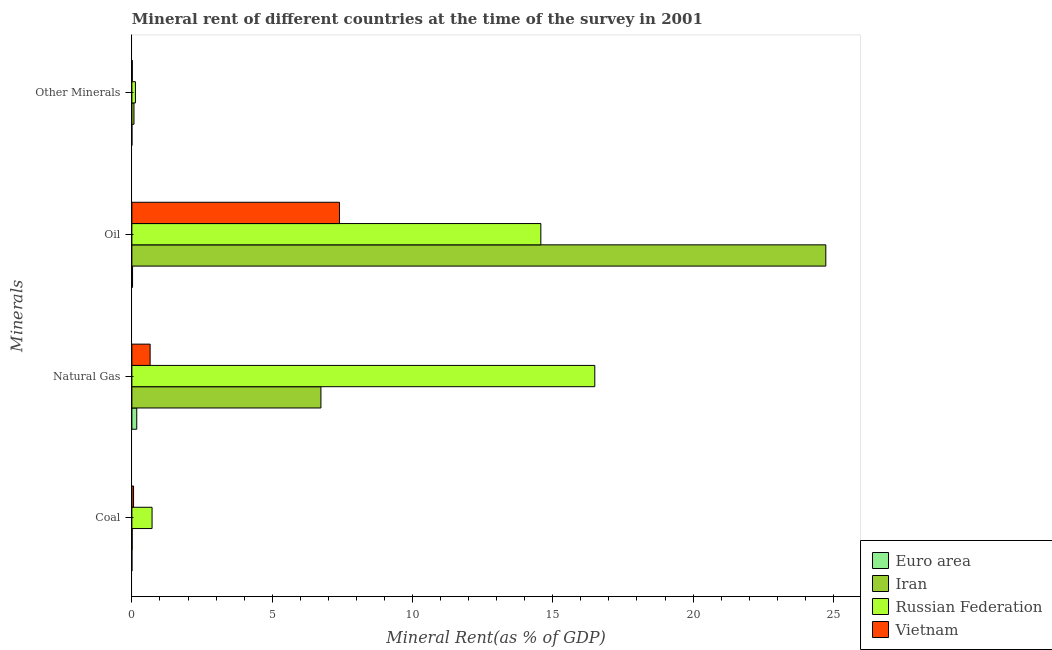Are the number of bars on each tick of the Y-axis equal?
Give a very brief answer. Yes. How many bars are there on the 3rd tick from the top?
Your answer should be very brief. 4. How many bars are there on the 2nd tick from the bottom?
Keep it short and to the point. 4. What is the label of the 2nd group of bars from the top?
Provide a succinct answer. Oil. What is the coal rent in Iran?
Give a very brief answer. 0.01. Across all countries, what is the maximum natural gas rent?
Provide a succinct answer. 16.5. Across all countries, what is the minimum coal rent?
Ensure brevity in your answer.  0. In which country was the natural gas rent maximum?
Give a very brief answer. Russian Federation. What is the total oil rent in the graph?
Your answer should be very brief. 46.73. What is the difference between the  rent of other minerals in Iran and that in Vietnam?
Give a very brief answer. 0.06. What is the difference between the natural gas rent in Russian Federation and the  rent of other minerals in Vietnam?
Offer a very short reply. 16.48. What is the average coal rent per country?
Your answer should be very brief. 0.2. What is the difference between the natural gas rent and coal rent in Vietnam?
Offer a terse response. 0.59. In how many countries, is the coal rent greater than 8 %?
Your response must be concise. 0. What is the ratio of the oil rent in Russian Federation to that in Vietnam?
Ensure brevity in your answer.  1.97. What is the difference between the highest and the second highest natural gas rent?
Provide a short and direct response. 9.76. What is the difference between the highest and the lowest  rent of other minerals?
Provide a succinct answer. 0.13. Is the sum of the coal rent in Euro area and Vietnam greater than the maximum natural gas rent across all countries?
Ensure brevity in your answer.  No. What does the 3rd bar from the top in Natural Gas represents?
Ensure brevity in your answer.  Iran. What does the 2nd bar from the bottom in Coal represents?
Offer a very short reply. Iran. Is it the case that in every country, the sum of the coal rent and natural gas rent is greater than the oil rent?
Your response must be concise. No. How many bars are there?
Ensure brevity in your answer.  16. How many countries are there in the graph?
Offer a terse response. 4. What is the difference between two consecutive major ticks on the X-axis?
Keep it short and to the point. 5. Does the graph contain grids?
Your response must be concise. No. How many legend labels are there?
Keep it short and to the point. 4. What is the title of the graph?
Your answer should be compact. Mineral rent of different countries at the time of the survey in 2001. Does "Lithuania" appear as one of the legend labels in the graph?
Keep it short and to the point. No. What is the label or title of the X-axis?
Your answer should be compact. Mineral Rent(as % of GDP). What is the label or title of the Y-axis?
Your response must be concise. Minerals. What is the Mineral Rent(as % of GDP) in Euro area in Coal?
Keep it short and to the point. 0. What is the Mineral Rent(as % of GDP) in Iran in Coal?
Your answer should be very brief. 0.01. What is the Mineral Rent(as % of GDP) in Russian Federation in Coal?
Provide a short and direct response. 0.72. What is the Mineral Rent(as % of GDP) in Vietnam in Coal?
Keep it short and to the point. 0.06. What is the Mineral Rent(as % of GDP) of Euro area in Natural Gas?
Provide a succinct answer. 0.17. What is the Mineral Rent(as % of GDP) of Iran in Natural Gas?
Provide a succinct answer. 6.74. What is the Mineral Rent(as % of GDP) in Russian Federation in Natural Gas?
Your answer should be very brief. 16.5. What is the Mineral Rent(as % of GDP) in Vietnam in Natural Gas?
Provide a short and direct response. 0.65. What is the Mineral Rent(as % of GDP) in Euro area in Oil?
Your response must be concise. 0.02. What is the Mineral Rent(as % of GDP) of Iran in Oil?
Your answer should be very brief. 24.73. What is the Mineral Rent(as % of GDP) in Russian Federation in Oil?
Offer a very short reply. 14.57. What is the Mineral Rent(as % of GDP) of Vietnam in Oil?
Ensure brevity in your answer.  7.4. What is the Mineral Rent(as % of GDP) in Euro area in Other Minerals?
Your response must be concise. 0. What is the Mineral Rent(as % of GDP) of Iran in Other Minerals?
Your answer should be very brief. 0.08. What is the Mineral Rent(as % of GDP) of Russian Federation in Other Minerals?
Your answer should be very brief. 0.13. What is the Mineral Rent(as % of GDP) of Vietnam in Other Minerals?
Your answer should be very brief. 0.01. Across all Minerals, what is the maximum Mineral Rent(as % of GDP) in Euro area?
Your answer should be compact. 0.17. Across all Minerals, what is the maximum Mineral Rent(as % of GDP) of Iran?
Ensure brevity in your answer.  24.73. Across all Minerals, what is the maximum Mineral Rent(as % of GDP) in Russian Federation?
Your answer should be very brief. 16.5. Across all Minerals, what is the maximum Mineral Rent(as % of GDP) in Vietnam?
Ensure brevity in your answer.  7.4. Across all Minerals, what is the minimum Mineral Rent(as % of GDP) of Euro area?
Provide a short and direct response. 0. Across all Minerals, what is the minimum Mineral Rent(as % of GDP) of Iran?
Provide a short and direct response. 0.01. Across all Minerals, what is the minimum Mineral Rent(as % of GDP) of Russian Federation?
Your response must be concise. 0.13. Across all Minerals, what is the minimum Mineral Rent(as % of GDP) of Vietnam?
Keep it short and to the point. 0.01. What is the total Mineral Rent(as % of GDP) of Euro area in the graph?
Your answer should be very brief. 0.2. What is the total Mineral Rent(as % of GDP) of Iran in the graph?
Your response must be concise. 31.55. What is the total Mineral Rent(as % of GDP) in Russian Federation in the graph?
Ensure brevity in your answer.  31.92. What is the total Mineral Rent(as % of GDP) in Vietnam in the graph?
Your answer should be compact. 8.12. What is the difference between the Mineral Rent(as % of GDP) of Euro area in Coal and that in Natural Gas?
Provide a short and direct response. -0.17. What is the difference between the Mineral Rent(as % of GDP) in Iran in Coal and that in Natural Gas?
Ensure brevity in your answer.  -6.73. What is the difference between the Mineral Rent(as % of GDP) in Russian Federation in Coal and that in Natural Gas?
Keep it short and to the point. -15.78. What is the difference between the Mineral Rent(as % of GDP) in Vietnam in Coal and that in Natural Gas?
Make the answer very short. -0.59. What is the difference between the Mineral Rent(as % of GDP) of Euro area in Coal and that in Oil?
Your answer should be compact. -0.02. What is the difference between the Mineral Rent(as % of GDP) of Iran in Coal and that in Oil?
Ensure brevity in your answer.  -24.72. What is the difference between the Mineral Rent(as % of GDP) in Russian Federation in Coal and that in Oil?
Provide a short and direct response. -13.86. What is the difference between the Mineral Rent(as % of GDP) in Vietnam in Coal and that in Oil?
Give a very brief answer. -7.34. What is the difference between the Mineral Rent(as % of GDP) in Iran in Coal and that in Other Minerals?
Provide a short and direct response. -0.06. What is the difference between the Mineral Rent(as % of GDP) in Russian Federation in Coal and that in Other Minerals?
Provide a succinct answer. 0.59. What is the difference between the Mineral Rent(as % of GDP) in Vietnam in Coal and that in Other Minerals?
Your answer should be very brief. 0.05. What is the difference between the Mineral Rent(as % of GDP) of Euro area in Natural Gas and that in Oil?
Your answer should be very brief. 0.15. What is the difference between the Mineral Rent(as % of GDP) of Iran in Natural Gas and that in Oil?
Your answer should be compact. -17.99. What is the difference between the Mineral Rent(as % of GDP) in Russian Federation in Natural Gas and that in Oil?
Offer a very short reply. 1.92. What is the difference between the Mineral Rent(as % of GDP) in Vietnam in Natural Gas and that in Oil?
Offer a very short reply. -6.75. What is the difference between the Mineral Rent(as % of GDP) of Euro area in Natural Gas and that in Other Minerals?
Make the answer very short. 0.17. What is the difference between the Mineral Rent(as % of GDP) of Iran in Natural Gas and that in Other Minerals?
Keep it short and to the point. 6.66. What is the difference between the Mineral Rent(as % of GDP) of Russian Federation in Natural Gas and that in Other Minerals?
Offer a terse response. 16.37. What is the difference between the Mineral Rent(as % of GDP) of Vietnam in Natural Gas and that in Other Minerals?
Offer a very short reply. 0.64. What is the difference between the Mineral Rent(as % of GDP) of Euro area in Oil and that in Other Minerals?
Offer a terse response. 0.02. What is the difference between the Mineral Rent(as % of GDP) in Iran in Oil and that in Other Minerals?
Provide a short and direct response. 24.66. What is the difference between the Mineral Rent(as % of GDP) of Russian Federation in Oil and that in Other Minerals?
Ensure brevity in your answer.  14.45. What is the difference between the Mineral Rent(as % of GDP) of Vietnam in Oil and that in Other Minerals?
Offer a terse response. 7.38. What is the difference between the Mineral Rent(as % of GDP) of Euro area in Coal and the Mineral Rent(as % of GDP) of Iran in Natural Gas?
Ensure brevity in your answer.  -6.74. What is the difference between the Mineral Rent(as % of GDP) of Euro area in Coal and the Mineral Rent(as % of GDP) of Russian Federation in Natural Gas?
Offer a terse response. -16.5. What is the difference between the Mineral Rent(as % of GDP) of Euro area in Coal and the Mineral Rent(as % of GDP) of Vietnam in Natural Gas?
Your response must be concise. -0.65. What is the difference between the Mineral Rent(as % of GDP) of Iran in Coal and the Mineral Rent(as % of GDP) of Russian Federation in Natural Gas?
Ensure brevity in your answer.  -16.49. What is the difference between the Mineral Rent(as % of GDP) of Iran in Coal and the Mineral Rent(as % of GDP) of Vietnam in Natural Gas?
Your answer should be compact. -0.64. What is the difference between the Mineral Rent(as % of GDP) of Russian Federation in Coal and the Mineral Rent(as % of GDP) of Vietnam in Natural Gas?
Keep it short and to the point. 0.07. What is the difference between the Mineral Rent(as % of GDP) of Euro area in Coal and the Mineral Rent(as % of GDP) of Iran in Oil?
Offer a terse response. -24.73. What is the difference between the Mineral Rent(as % of GDP) of Euro area in Coal and the Mineral Rent(as % of GDP) of Russian Federation in Oil?
Make the answer very short. -14.57. What is the difference between the Mineral Rent(as % of GDP) of Euro area in Coal and the Mineral Rent(as % of GDP) of Vietnam in Oil?
Your answer should be very brief. -7.4. What is the difference between the Mineral Rent(as % of GDP) of Iran in Coal and the Mineral Rent(as % of GDP) of Russian Federation in Oil?
Make the answer very short. -14.56. What is the difference between the Mineral Rent(as % of GDP) in Iran in Coal and the Mineral Rent(as % of GDP) in Vietnam in Oil?
Ensure brevity in your answer.  -7.39. What is the difference between the Mineral Rent(as % of GDP) in Russian Federation in Coal and the Mineral Rent(as % of GDP) in Vietnam in Oil?
Your answer should be very brief. -6.68. What is the difference between the Mineral Rent(as % of GDP) of Euro area in Coal and the Mineral Rent(as % of GDP) of Iran in Other Minerals?
Keep it short and to the point. -0.07. What is the difference between the Mineral Rent(as % of GDP) of Euro area in Coal and the Mineral Rent(as % of GDP) of Russian Federation in Other Minerals?
Give a very brief answer. -0.13. What is the difference between the Mineral Rent(as % of GDP) in Euro area in Coal and the Mineral Rent(as % of GDP) in Vietnam in Other Minerals?
Ensure brevity in your answer.  -0.01. What is the difference between the Mineral Rent(as % of GDP) of Iran in Coal and the Mineral Rent(as % of GDP) of Russian Federation in Other Minerals?
Make the answer very short. -0.12. What is the difference between the Mineral Rent(as % of GDP) of Iran in Coal and the Mineral Rent(as % of GDP) of Vietnam in Other Minerals?
Give a very brief answer. -0. What is the difference between the Mineral Rent(as % of GDP) of Russian Federation in Coal and the Mineral Rent(as % of GDP) of Vietnam in Other Minerals?
Your answer should be very brief. 0.7. What is the difference between the Mineral Rent(as % of GDP) in Euro area in Natural Gas and the Mineral Rent(as % of GDP) in Iran in Oil?
Keep it short and to the point. -24.56. What is the difference between the Mineral Rent(as % of GDP) in Euro area in Natural Gas and the Mineral Rent(as % of GDP) in Russian Federation in Oil?
Your answer should be compact. -14.4. What is the difference between the Mineral Rent(as % of GDP) of Euro area in Natural Gas and the Mineral Rent(as % of GDP) of Vietnam in Oil?
Provide a short and direct response. -7.22. What is the difference between the Mineral Rent(as % of GDP) in Iran in Natural Gas and the Mineral Rent(as % of GDP) in Russian Federation in Oil?
Offer a terse response. -7.84. What is the difference between the Mineral Rent(as % of GDP) in Iran in Natural Gas and the Mineral Rent(as % of GDP) in Vietnam in Oil?
Offer a terse response. -0.66. What is the difference between the Mineral Rent(as % of GDP) in Russian Federation in Natural Gas and the Mineral Rent(as % of GDP) in Vietnam in Oil?
Provide a short and direct response. 9.1. What is the difference between the Mineral Rent(as % of GDP) in Euro area in Natural Gas and the Mineral Rent(as % of GDP) in Iran in Other Minerals?
Ensure brevity in your answer.  0.1. What is the difference between the Mineral Rent(as % of GDP) in Euro area in Natural Gas and the Mineral Rent(as % of GDP) in Russian Federation in Other Minerals?
Offer a terse response. 0.05. What is the difference between the Mineral Rent(as % of GDP) of Euro area in Natural Gas and the Mineral Rent(as % of GDP) of Vietnam in Other Minerals?
Make the answer very short. 0.16. What is the difference between the Mineral Rent(as % of GDP) in Iran in Natural Gas and the Mineral Rent(as % of GDP) in Russian Federation in Other Minerals?
Your answer should be very brief. 6.61. What is the difference between the Mineral Rent(as % of GDP) of Iran in Natural Gas and the Mineral Rent(as % of GDP) of Vietnam in Other Minerals?
Offer a terse response. 6.72. What is the difference between the Mineral Rent(as % of GDP) in Russian Federation in Natural Gas and the Mineral Rent(as % of GDP) in Vietnam in Other Minerals?
Provide a short and direct response. 16.48. What is the difference between the Mineral Rent(as % of GDP) of Euro area in Oil and the Mineral Rent(as % of GDP) of Iran in Other Minerals?
Ensure brevity in your answer.  -0.05. What is the difference between the Mineral Rent(as % of GDP) of Euro area in Oil and the Mineral Rent(as % of GDP) of Russian Federation in Other Minerals?
Keep it short and to the point. -0.1. What is the difference between the Mineral Rent(as % of GDP) of Euro area in Oil and the Mineral Rent(as % of GDP) of Vietnam in Other Minerals?
Your answer should be compact. 0.01. What is the difference between the Mineral Rent(as % of GDP) of Iran in Oil and the Mineral Rent(as % of GDP) of Russian Federation in Other Minerals?
Ensure brevity in your answer.  24.6. What is the difference between the Mineral Rent(as % of GDP) in Iran in Oil and the Mineral Rent(as % of GDP) in Vietnam in Other Minerals?
Offer a very short reply. 24.72. What is the difference between the Mineral Rent(as % of GDP) of Russian Federation in Oil and the Mineral Rent(as % of GDP) of Vietnam in Other Minerals?
Provide a short and direct response. 14.56. What is the average Mineral Rent(as % of GDP) in Euro area per Minerals?
Offer a very short reply. 0.05. What is the average Mineral Rent(as % of GDP) in Iran per Minerals?
Provide a succinct answer. 7.89. What is the average Mineral Rent(as % of GDP) of Russian Federation per Minerals?
Provide a short and direct response. 7.98. What is the average Mineral Rent(as % of GDP) in Vietnam per Minerals?
Give a very brief answer. 2.03. What is the difference between the Mineral Rent(as % of GDP) of Euro area and Mineral Rent(as % of GDP) of Iran in Coal?
Provide a short and direct response. -0.01. What is the difference between the Mineral Rent(as % of GDP) in Euro area and Mineral Rent(as % of GDP) in Russian Federation in Coal?
Provide a succinct answer. -0.72. What is the difference between the Mineral Rent(as % of GDP) of Euro area and Mineral Rent(as % of GDP) of Vietnam in Coal?
Keep it short and to the point. -0.06. What is the difference between the Mineral Rent(as % of GDP) of Iran and Mineral Rent(as % of GDP) of Russian Federation in Coal?
Ensure brevity in your answer.  -0.71. What is the difference between the Mineral Rent(as % of GDP) in Iran and Mineral Rent(as % of GDP) in Vietnam in Coal?
Ensure brevity in your answer.  -0.05. What is the difference between the Mineral Rent(as % of GDP) in Russian Federation and Mineral Rent(as % of GDP) in Vietnam in Coal?
Your answer should be compact. 0.66. What is the difference between the Mineral Rent(as % of GDP) of Euro area and Mineral Rent(as % of GDP) of Iran in Natural Gas?
Your answer should be very brief. -6.56. What is the difference between the Mineral Rent(as % of GDP) in Euro area and Mineral Rent(as % of GDP) in Russian Federation in Natural Gas?
Ensure brevity in your answer.  -16.32. What is the difference between the Mineral Rent(as % of GDP) in Euro area and Mineral Rent(as % of GDP) in Vietnam in Natural Gas?
Ensure brevity in your answer.  -0.48. What is the difference between the Mineral Rent(as % of GDP) in Iran and Mineral Rent(as % of GDP) in Russian Federation in Natural Gas?
Your response must be concise. -9.76. What is the difference between the Mineral Rent(as % of GDP) in Iran and Mineral Rent(as % of GDP) in Vietnam in Natural Gas?
Make the answer very short. 6.09. What is the difference between the Mineral Rent(as % of GDP) in Russian Federation and Mineral Rent(as % of GDP) in Vietnam in Natural Gas?
Provide a short and direct response. 15.85. What is the difference between the Mineral Rent(as % of GDP) in Euro area and Mineral Rent(as % of GDP) in Iran in Oil?
Provide a succinct answer. -24.71. What is the difference between the Mineral Rent(as % of GDP) of Euro area and Mineral Rent(as % of GDP) of Russian Federation in Oil?
Keep it short and to the point. -14.55. What is the difference between the Mineral Rent(as % of GDP) in Euro area and Mineral Rent(as % of GDP) in Vietnam in Oil?
Your answer should be compact. -7.37. What is the difference between the Mineral Rent(as % of GDP) of Iran and Mineral Rent(as % of GDP) of Russian Federation in Oil?
Your response must be concise. 10.16. What is the difference between the Mineral Rent(as % of GDP) of Iran and Mineral Rent(as % of GDP) of Vietnam in Oil?
Keep it short and to the point. 17.33. What is the difference between the Mineral Rent(as % of GDP) in Russian Federation and Mineral Rent(as % of GDP) in Vietnam in Oil?
Ensure brevity in your answer.  7.18. What is the difference between the Mineral Rent(as % of GDP) in Euro area and Mineral Rent(as % of GDP) in Iran in Other Minerals?
Provide a short and direct response. -0.07. What is the difference between the Mineral Rent(as % of GDP) in Euro area and Mineral Rent(as % of GDP) in Russian Federation in Other Minerals?
Your answer should be compact. -0.13. What is the difference between the Mineral Rent(as % of GDP) in Euro area and Mineral Rent(as % of GDP) in Vietnam in Other Minerals?
Provide a short and direct response. -0.01. What is the difference between the Mineral Rent(as % of GDP) of Iran and Mineral Rent(as % of GDP) of Russian Federation in Other Minerals?
Offer a terse response. -0.05. What is the difference between the Mineral Rent(as % of GDP) of Iran and Mineral Rent(as % of GDP) of Vietnam in Other Minerals?
Your answer should be compact. 0.06. What is the difference between the Mineral Rent(as % of GDP) in Russian Federation and Mineral Rent(as % of GDP) in Vietnam in Other Minerals?
Make the answer very short. 0.11. What is the ratio of the Mineral Rent(as % of GDP) in Euro area in Coal to that in Natural Gas?
Give a very brief answer. 0. What is the ratio of the Mineral Rent(as % of GDP) of Iran in Coal to that in Natural Gas?
Keep it short and to the point. 0. What is the ratio of the Mineral Rent(as % of GDP) of Russian Federation in Coal to that in Natural Gas?
Provide a short and direct response. 0.04. What is the ratio of the Mineral Rent(as % of GDP) of Vietnam in Coal to that in Natural Gas?
Provide a short and direct response. 0.09. What is the ratio of the Mineral Rent(as % of GDP) in Euro area in Coal to that in Oil?
Give a very brief answer. 0.02. What is the ratio of the Mineral Rent(as % of GDP) in Russian Federation in Coal to that in Oil?
Offer a terse response. 0.05. What is the ratio of the Mineral Rent(as % of GDP) of Vietnam in Coal to that in Oil?
Give a very brief answer. 0.01. What is the ratio of the Mineral Rent(as % of GDP) in Euro area in Coal to that in Other Minerals?
Your answer should be very brief. 1.13. What is the ratio of the Mineral Rent(as % of GDP) in Iran in Coal to that in Other Minerals?
Give a very brief answer. 0.14. What is the ratio of the Mineral Rent(as % of GDP) of Russian Federation in Coal to that in Other Minerals?
Keep it short and to the point. 5.67. What is the ratio of the Mineral Rent(as % of GDP) in Vietnam in Coal to that in Other Minerals?
Your answer should be very brief. 4.01. What is the ratio of the Mineral Rent(as % of GDP) in Euro area in Natural Gas to that in Oil?
Your answer should be compact. 7.18. What is the ratio of the Mineral Rent(as % of GDP) in Iran in Natural Gas to that in Oil?
Offer a very short reply. 0.27. What is the ratio of the Mineral Rent(as % of GDP) in Russian Federation in Natural Gas to that in Oil?
Your answer should be compact. 1.13. What is the ratio of the Mineral Rent(as % of GDP) of Vietnam in Natural Gas to that in Oil?
Offer a terse response. 0.09. What is the ratio of the Mineral Rent(as % of GDP) of Euro area in Natural Gas to that in Other Minerals?
Give a very brief answer. 466.8. What is the ratio of the Mineral Rent(as % of GDP) of Iran in Natural Gas to that in Other Minerals?
Give a very brief answer. 89.66. What is the ratio of the Mineral Rent(as % of GDP) of Russian Federation in Natural Gas to that in Other Minerals?
Your answer should be compact. 130.03. What is the ratio of the Mineral Rent(as % of GDP) in Vietnam in Natural Gas to that in Other Minerals?
Give a very brief answer. 43.41. What is the ratio of the Mineral Rent(as % of GDP) in Euro area in Oil to that in Other Minerals?
Provide a short and direct response. 65.03. What is the ratio of the Mineral Rent(as % of GDP) in Iran in Oil to that in Other Minerals?
Provide a succinct answer. 329.13. What is the ratio of the Mineral Rent(as % of GDP) of Russian Federation in Oil to that in Other Minerals?
Your answer should be very brief. 114.88. What is the ratio of the Mineral Rent(as % of GDP) in Vietnam in Oil to that in Other Minerals?
Provide a short and direct response. 493.94. What is the difference between the highest and the second highest Mineral Rent(as % of GDP) in Euro area?
Provide a short and direct response. 0.15. What is the difference between the highest and the second highest Mineral Rent(as % of GDP) in Iran?
Provide a short and direct response. 17.99. What is the difference between the highest and the second highest Mineral Rent(as % of GDP) of Russian Federation?
Offer a very short reply. 1.92. What is the difference between the highest and the second highest Mineral Rent(as % of GDP) in Vietnam?
Keep it short and to the point. 6.75. What is the difference between the highest and the lowest Mineral Rent(as % of GDP) of Euro area?
Provide a succinct answer. 0.17. What is the difference between the highest and the lowest Mineral Rent(as % of GDP) in Iran?
Provide a succinct answer. 24.72. What is the difference between the highest and the lowest Mineral Rent(as % of GDP) of Russian Federation?
Ensure brevity in your answer.  16.37. What is the difference between the highest and the lowest Mineral Rent(as % of GDP) of Vietnam?
Give a very brief answer. 7.38. 